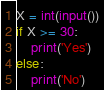Convert code to text. <code><loc_0><loc_0><loc_500><loc_500><_Python_>X = int(input())
if X >= 30:
    print('Yes')
else:
    print('No')</code> 